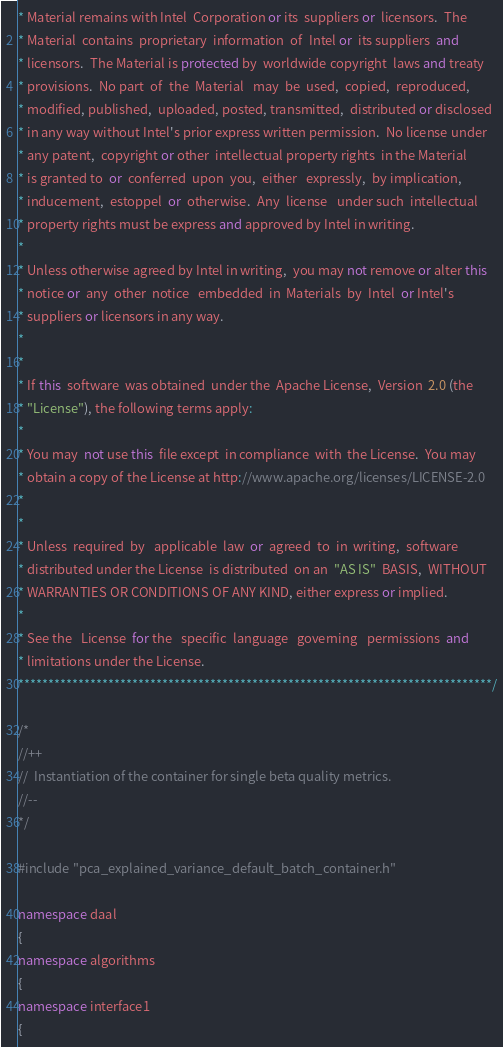<code> <loc_0><loc_0><loc_500><loc_500><_C++_>* Material remains with Intel  Corporation or its  suppliers or  licensors.  The
* Material  contains  proprietary  information  of  Intel or  its suppliers  and
* licensors.  The Material is protected by  worldwide copyright  laws and treaty
* provisions.  No part  of  the  Material   may  be  used,  copied,  reproduced,
* modified, published,  uploaded, posted, transmitted,  distributed or disclosed
* in any way without Intel's prior express written permission.  No license under
* any patent,  copyright or other  intellectual property rights  in the Material
* is granted to  or  conferred  upon  you,  either   expressly,  by implication,
* inducement,  estoppel  or  otherwise.  Any  license   under such  intellectual
* property rights must be express and approved by Intel in writing.
*
* Unless otherwise agreed by Intel in writing,  you may not remove or alter this
* notice or  any  other  notice   embedded  in  Materials  by  Intel  or Intel's
* suppliers or licensors in any way.
*
*
* If this  software  was obtained  under the  Apache License,  Version  2.0 (the
* "License"), the following terms apply:
*
* You may  not use this  file except  in compliance  with  the License.  You may
* obtain a copy of the License at http://www.apache.org/licenses/LICENSE-2.0
*
*
* Unless  required  by   applicable  law  or  agreed  to  in  writing,  software
* distributed under the License  is distributed  on an  "AS IS"  BASIS,  WITHOUT
* WARRANTIES OR CONDITIONS OF ANY KIND, either express or implied.
*
* See the   License  for the   specific  language   governing   permissions  and
* limitations under the License.
*******************************************************************************/

/*
//++
//  Instantiation of the container for single beta quality metrics.
//--
*/

#include "pca_explained_variance_default_batch_container.h"

namespace daal
{
namespace algorithms
{
namespace interface1
{</code> 